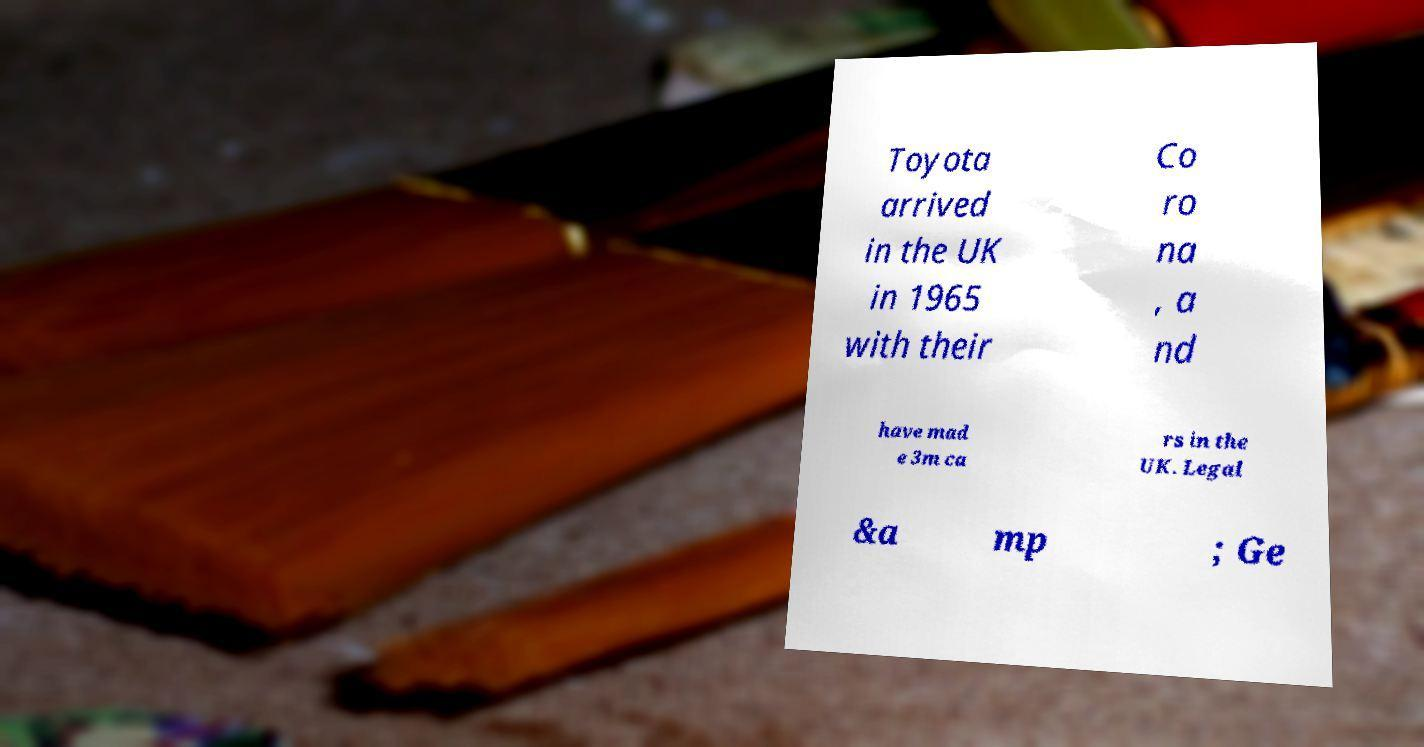What messages or text are displayed in this image? I need them in a readable, typed format. Toyota arrived in the UK in 1965 with their Co ro na , a nd have mad e 3m ca rs in the UK. Legal &a mp ; Ge 